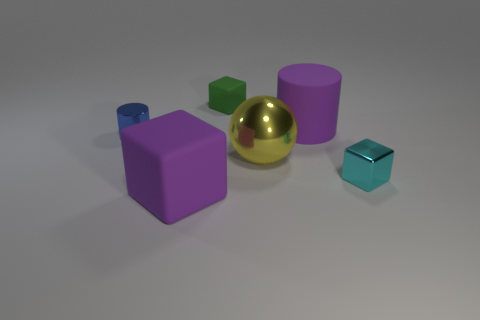Is there anything in the image that indicates the scale or the actual size of these objects? There are no familiar objects or markers of scale in the image that provide explicit context for the absolute size of these objects. Without additional information or external references, the actual size remains ambiguous, and viewers can only make relative size comparisons among the items shown. 